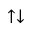Convert formula to latex. <formula><loc_0><loc_0><loc_500><loc_500>\uparrow \downarrow</formula> 